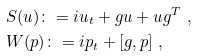<formula> <loc_0><loc_0><loc_500><loc_500>& S ( u ) \colon = i u _ { t } + g u + u g ^ { T } \ , \\ & W ( p ) \colon = i p _ { t } + [ g , p ] \ ,</formula> 